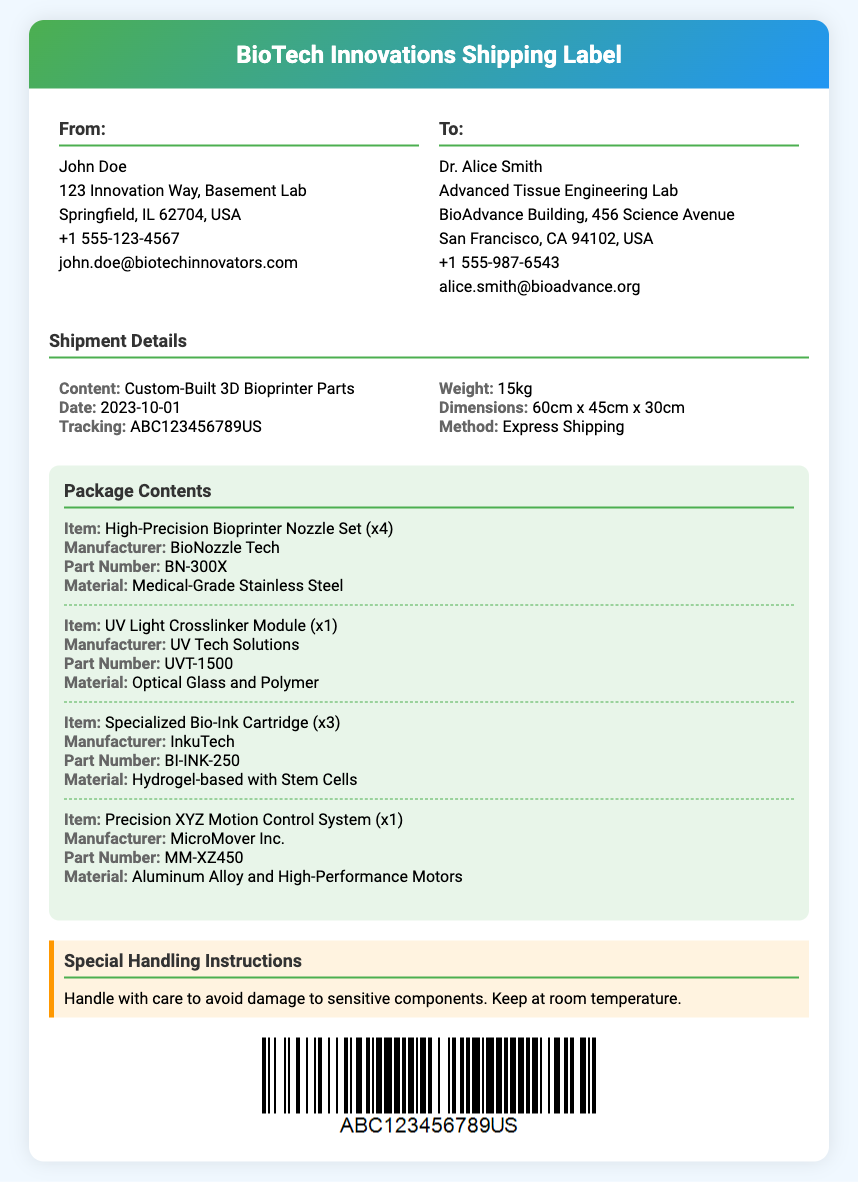What is the sender's name? The sender's name is listed in the "From" section of the document.
Answer: John Doe What is the recipient's email address? The recipient's email address is provided in the "To" section of the document.
Answer: alice.smith@bioadvance.org What is the shipment date? The shipment date is mentioned in the "Shipment Details" section.
Answer: 2023-10-01 What is the weight of the package? The weight of the package is specified in the "Shipment Details" section.
Answer: 15kg How many items of the High-Precision Bioprinter Nozzle Set are included? The quantity of the High-Precision Bioprinter Nozzle Set is mentioned under "Package Contents."
Answer: x4 What material is the Specialized Bio-Ink Cartridge made of? The material of the Specialized Bio-Ink Cartridge can be found in the "Package Contents" section.
Answer: Hydrogel-based with Stem Cells What special handling instructions are provided? The special handling instructions are detailed in the corresponding section of the document.
Answer: Handle with care to avoid damage to sensitive components. Keep at room temperature What is the part number of the UV Light Crosslinker Module? The part number for the UV Light Crosslinker Module is listed in the "Package Contents."
Answer: UVT-1500 What shipping method is used? The shipping method is specified in the "Shipment Details" section.
Answer: Express Shipping 